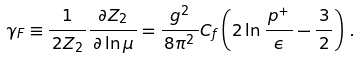Convert formula to latex. <formula><loc_0><loc_0><loc_500><loc_500>\gamma _ { F } \equiv \frac { 1 } { \, 2 Z _ { 2 } \, } \frac { \partial Z _ { 2 } } { \, \partial \ln \mu \, } = \frac { g ^ { 2 } } { \, 8 \pi ^ { 2 } \, } C _ { f } \left ( 2 \ln \frac { \, p ^ { + } \, } { \epsilon } - \frac { \, 3 \, } { 2 } \right ) \, .</formula> 